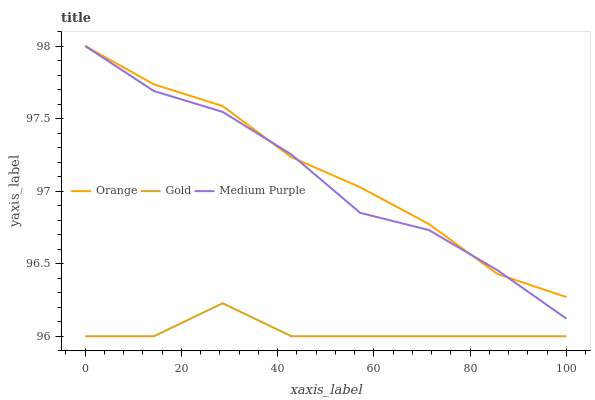Does Gold have the minimum area under the curve?
Answer yes or no. Yes. Does Orange have the maximum area under the curve?
Answer yes or no. Yes. Does Medium Purple have the minimum area under the curve?
Answer yes or no. No. Does Medium Purple have the maximum area under the curve?
Answer yes or no. No. Is Orange the smoothest?
Answer yes or no. Yes. Is Medium Purple the roughest?
Answer yes or no. Yes. Is Gold the smoothest?
Answer yes or no. No. Is Gold the roughest?
Answer yes or no. No. Does Gold have the lowest value?
Answer yes or no. Yes. Does Medium Purple have the lowest value?
Answer yes or no. No. Does Medium Purple have the highest value?
Answer yes or no. Yes. Does Gold have the highest value?
Answer yes or no. No. Is Gold less than Medium Purple?
Answer yes or no. Yes. Is Medium Purple greater than Gold?
Answer yes or no. Yes. Does Medium Purple intersect Orange?
Answer yes or no. Yes. Is Medium Purple less than Orange?
Answer yes or no. No. Is Medium Purple greater than Orange?
Answer yes or no. No. Does Gold intersect Medium Purple?
Answer yes or no. No. 